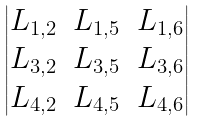Convert formula to latex. <formula><loc_0><loc_0><loc_500><loc_500>\begin{vmatrix} L _ { 1 , 2 } & L _ { 1 , 5 } & L _ { 1 , 6 } \\ L _ { 3 , 2 } & L _ { 3 , 5 } & L _ { 3 , 6 } \\ L _ { 4 , 2 } & L _ { 4 , 5 } & L _ { 4 , 6 } \end{vmatrix}</formula> 